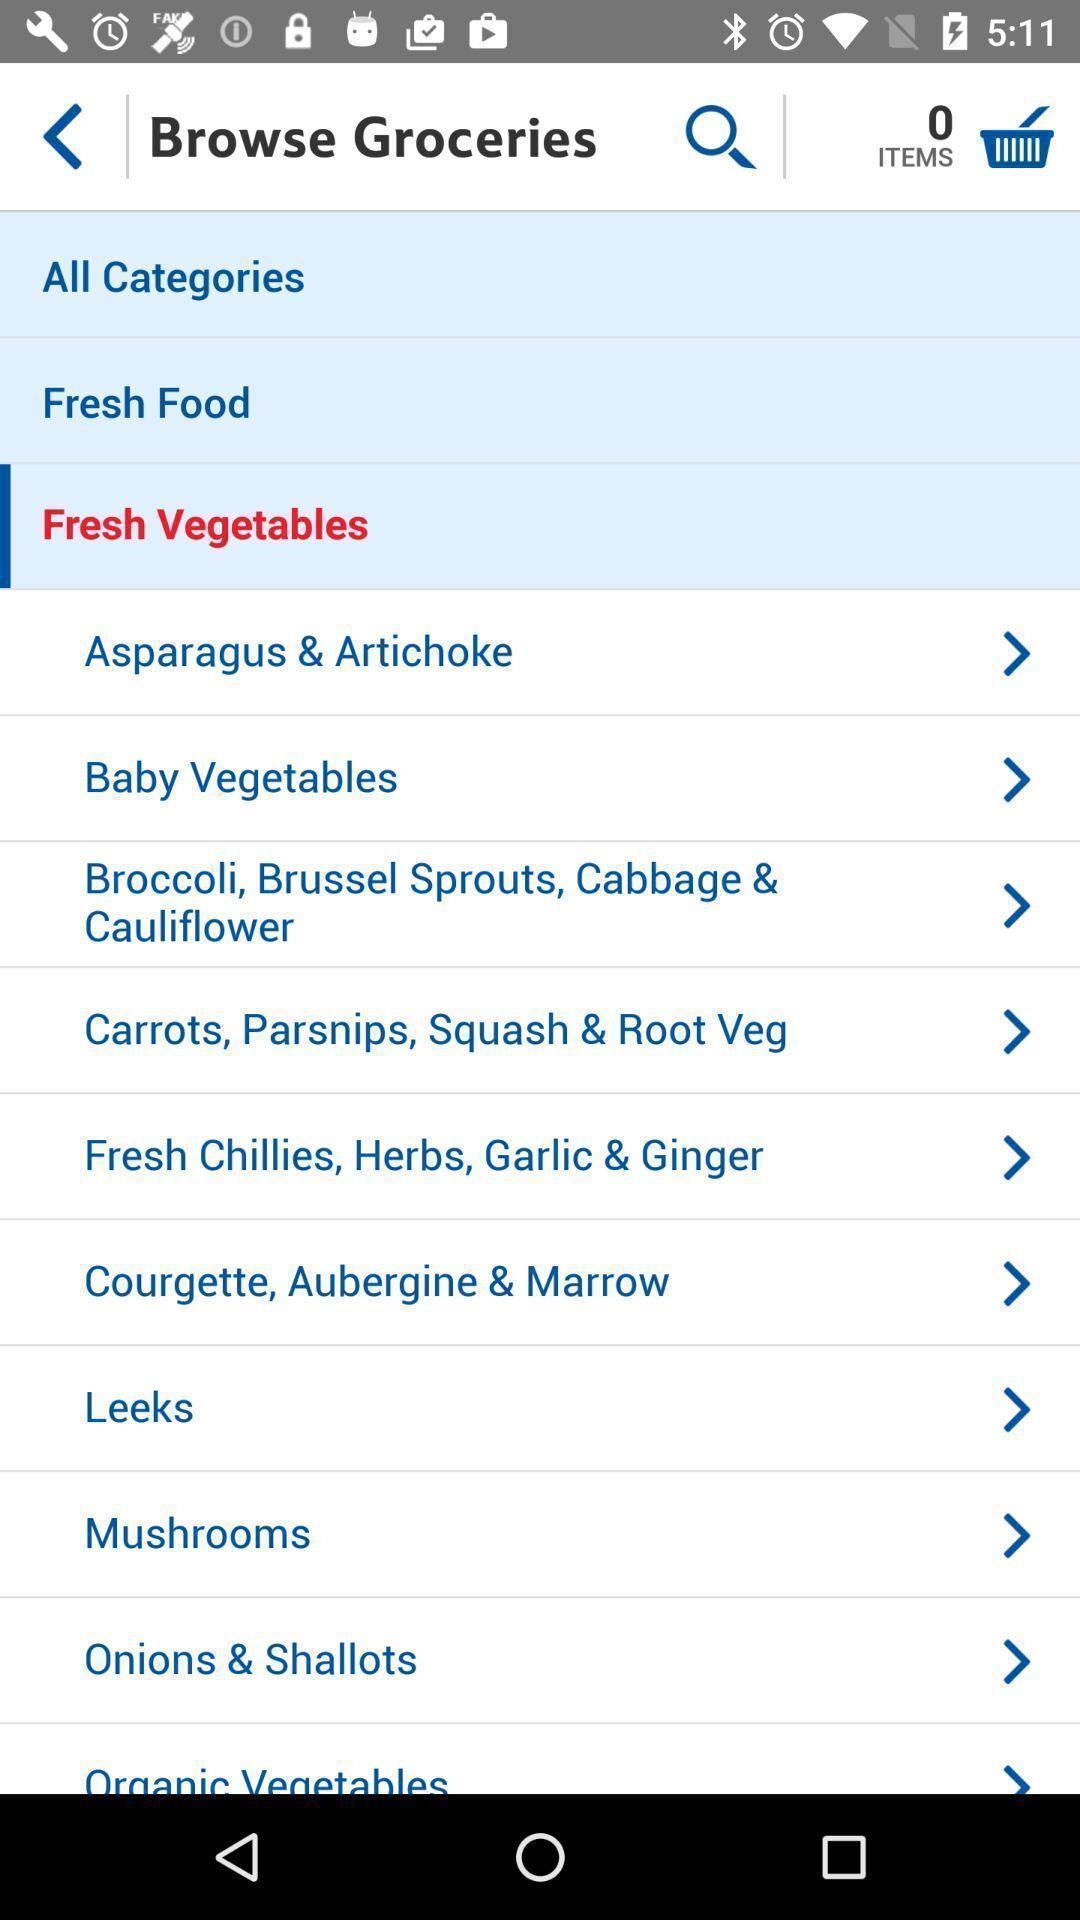What details can you identify in this image? Screen displaying the page to browse groceries. 